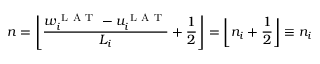<formula> <loc_0><loc_0><loc_500><loc_500>n = \left \lfloor \frac { w _ { i } ^ { L A T } - u _ { i } ^ { L A T } } { L _ { i } } + \frac { 1 } { 2 } \right \rfloor = \left \lfloor n _ { i } + \frac { 1 } { 2 } \right \rfloor \equiv n _ { i }</formula> 